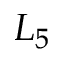Convert formula to latex. <formula><loc_0><loc_0><loc_500><loc_500>L _ { 5 }</formula> 